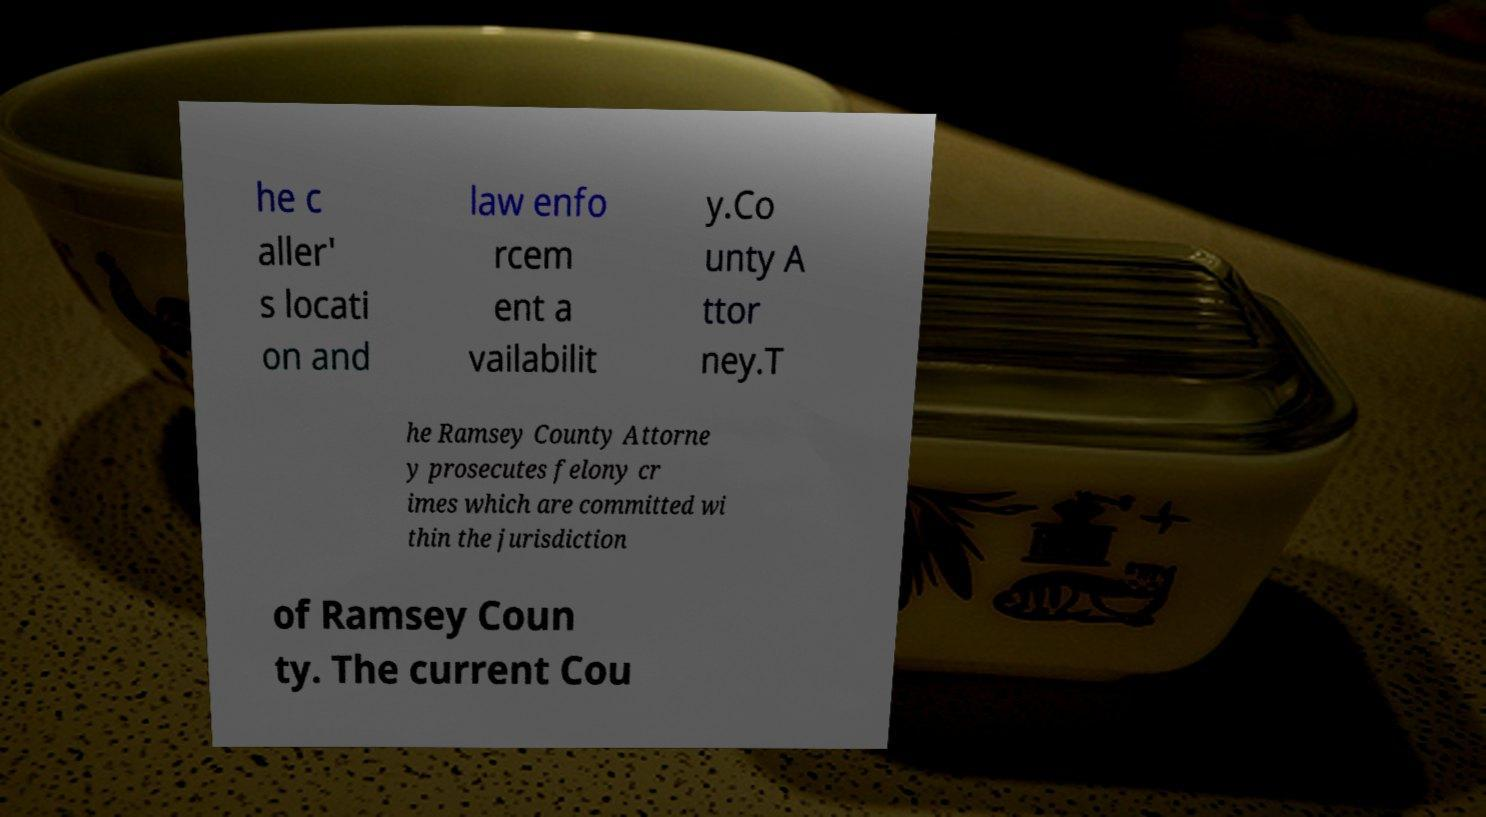For documentation purposes, I need the text within this image transcribed. Could you provide that? he c aller' s locati on and law enfo rcem ent a vailabilit y.Co unty A ttor ney.T he Ramsey County Attorne y prosecutes felony cr imes which are committed wi thin the jurisdiction of Ramsey Coun ty. The current Cou 